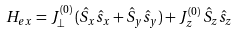<formula> <loc_0><loc_0><loc_500><loc_500>H _ { e x } = J ^ { ( 0 ) } _ { \perp } \, ( \hat { S } _ { x } \hat { s } _ { x } + \hat { S } _ { y } \hat { s } _ { y } ) + J ^ { ( 0 ) } _ { z } \, \hat { S } _ { z } \hat { s } _ { z }</formula> 